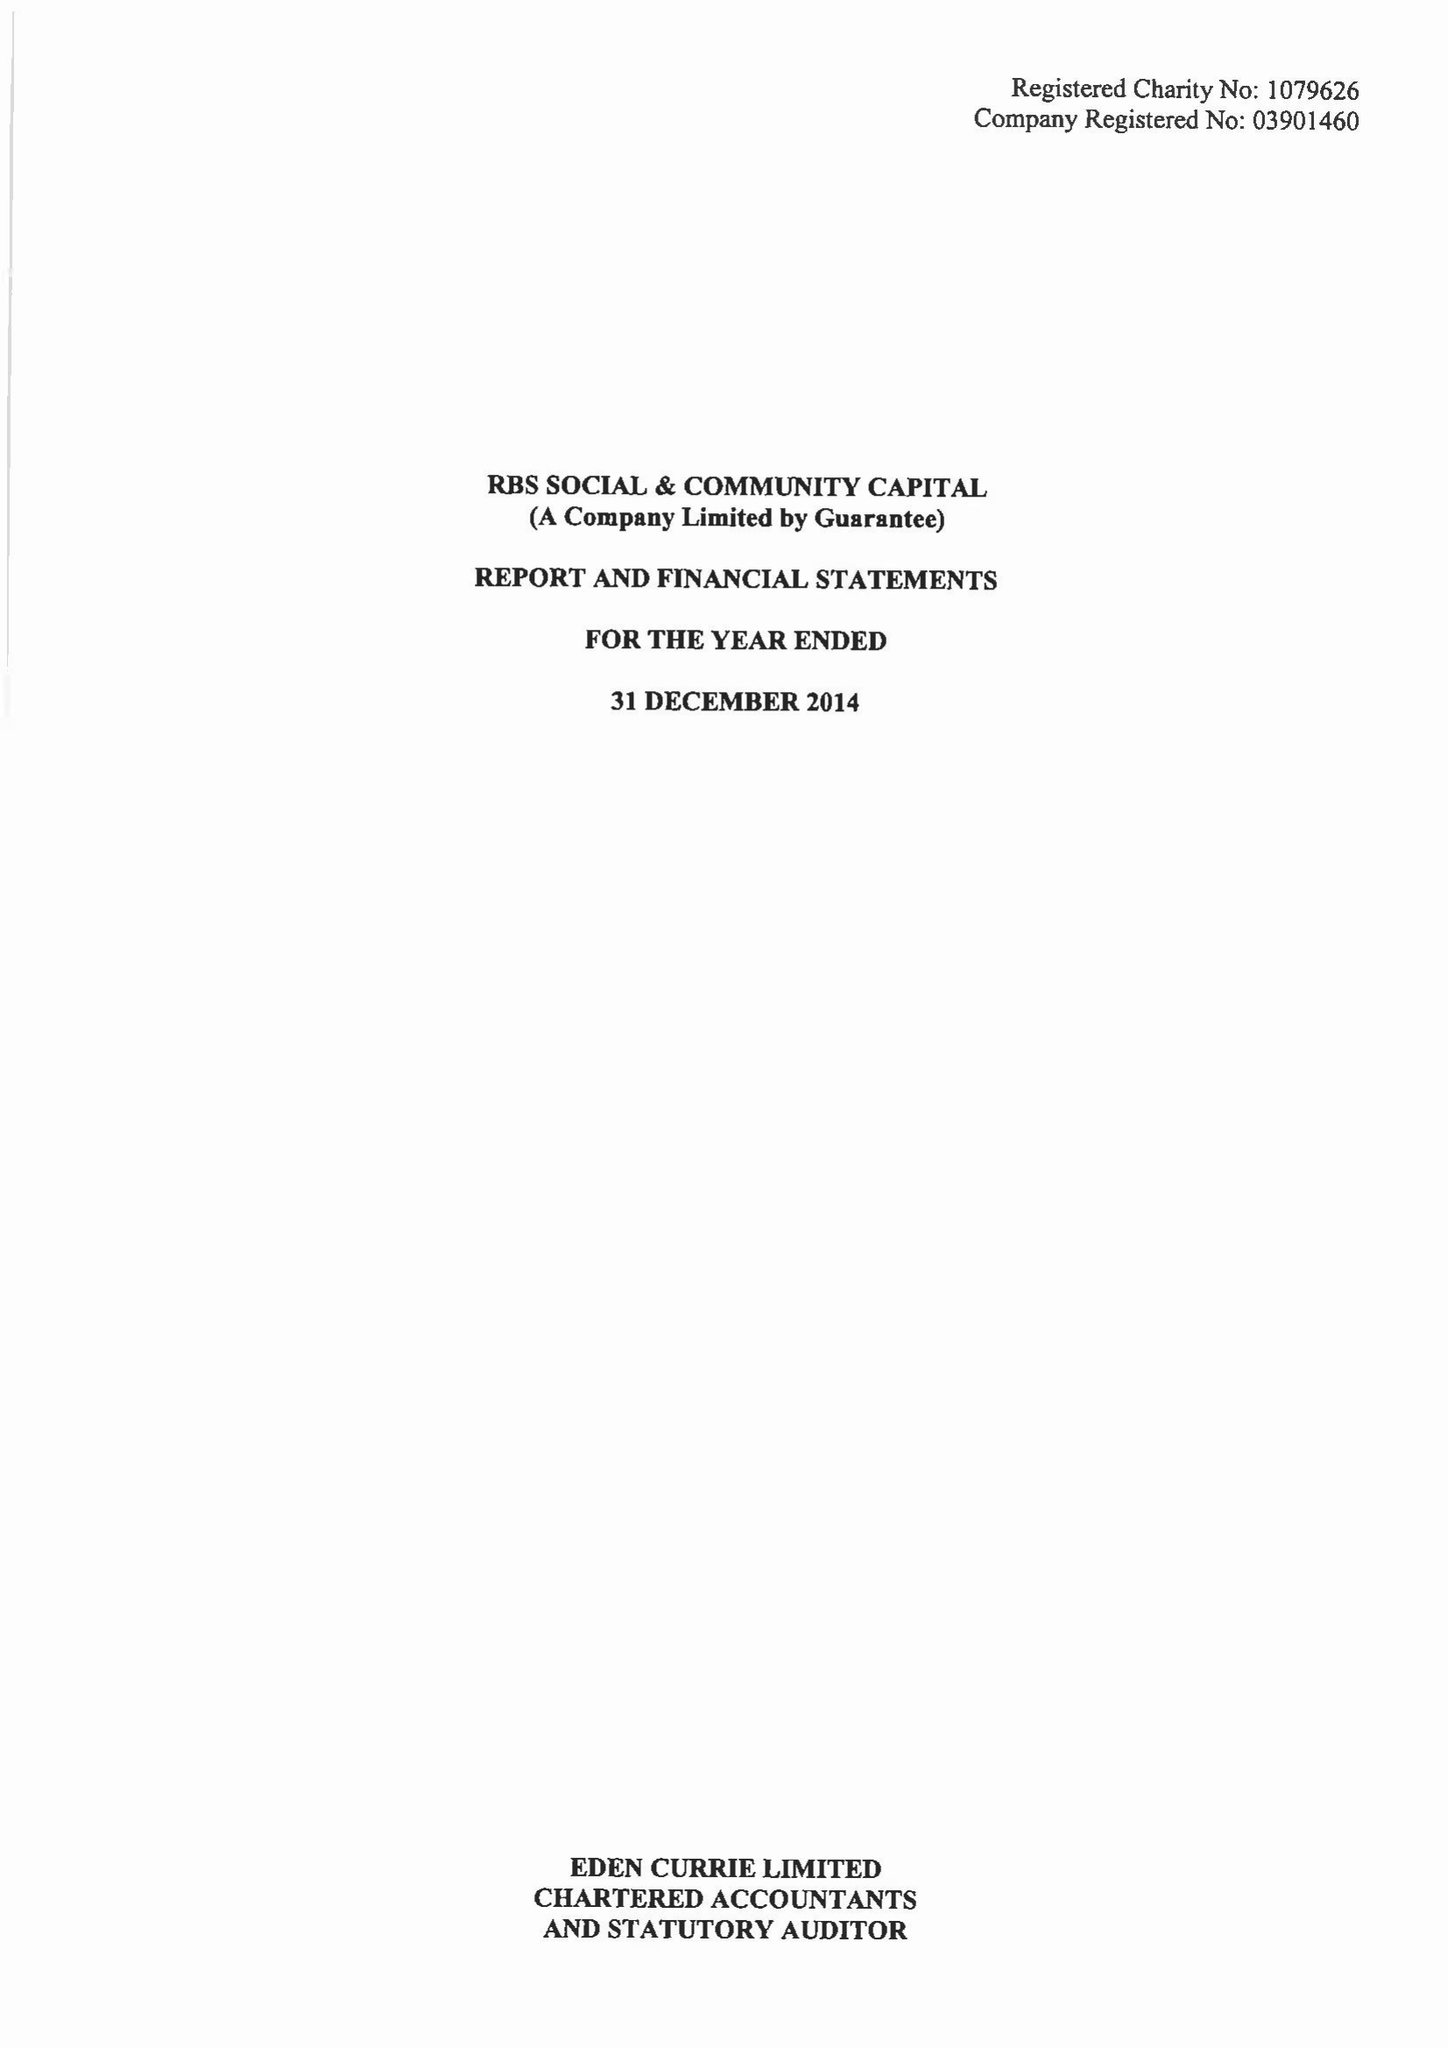What is the value for the report_date?
Answer the question using a single word or phrase. 2014-12-31 